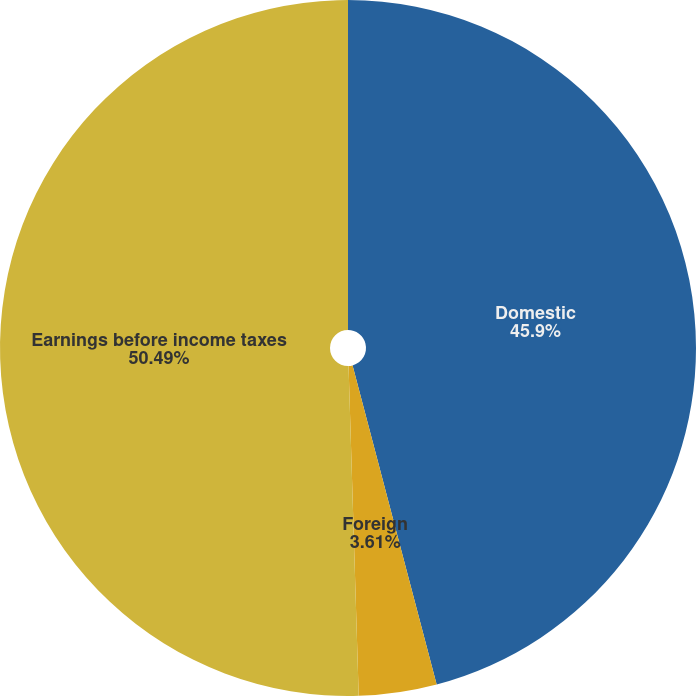Convert chart. <chart><loc_0><loc_0><loc_500><loc_500><pie_chart><fcel>Domestic<fcel>Foreign<fcel>Earnings before income taxes<nl><fcel>45.9%<fcel>3.61%<fcel>50.49%<nl></chart> 